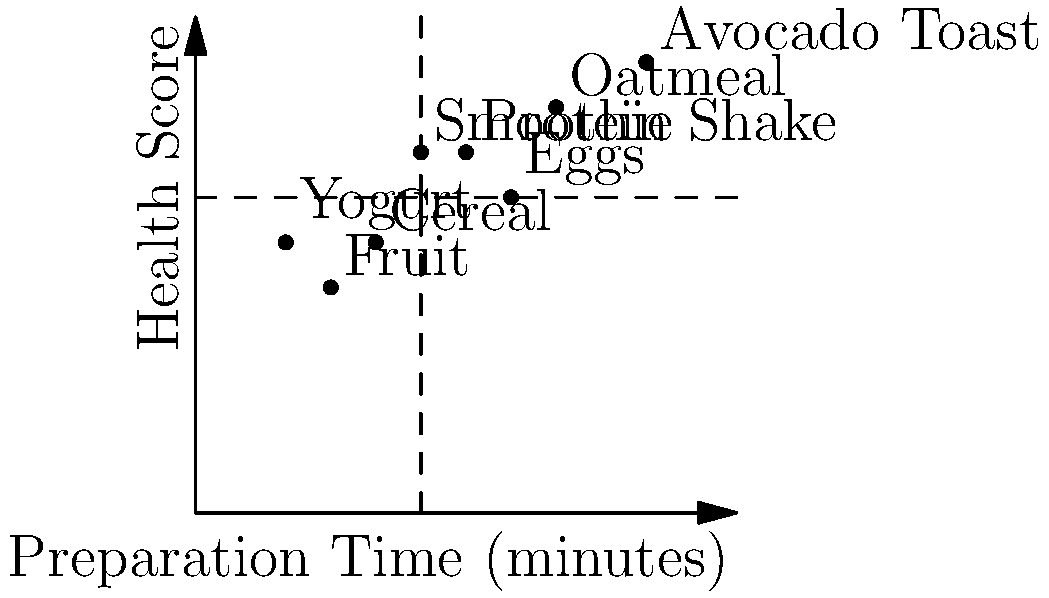Based on the scatter plot showing various breakfast options, their preparation times, and health scores, which options would be most suitable for a quick (under 5 minutes) and healthy (health score above 7) breakfast? To answer this question, we need to analyze the scatter plot and identify the breakfast options that meet both criteria:
1. Preparation time under 5 minutes
2. Health score above 7

Step 1: Identify the relevant quadrant
The ideal options will be located in the upper-left quadrant of the plot, defined by the intersection of the vertical line at x=5 (preparation time) and the horizontal line at y=7 (health score).

Step 2: Analyze each option
- Yogurt: Prep time ≈ 2 min, Health score ≈ 6 (Quick but not healthy enough)
- Smoothie: Prep time ≈ 5 min, Health score ≈ 8 (Borderline prep time, healthy)
- Oatmeal: Prep time ≈ 8 min, Health score ≈ 9 (Too long prep time)
- Fruit: Prep time ≈ 3 min, Health score ≈ 5 (Quick but not healthy enough)
- Avocado Toast: Prep time ≈ 10 min, Health score ≈ 10 (Too long prep time)
- Eggs: Prep time ≈ 7 min, Health score ≈ 7 (Too long prep time)
- Cereal: Prep time ≈ 4 min, Health score ≈ 6 (Quick but not healthy enough)
- Protein Shake: Prep time ≈ 6 min, Health score ≈ 8 (Too long prep time)

Step 3: Identify options meeting both criteria
The only option that falls in the desired quadrant (upper-left) is the Smoothie, with a preparation time of about 5 minutes and a health score of 8.

Step 4: Consider borderline options
While not strictly under 5 minutes, the Protein Shake is close (6 minutes) and has a high health score (8). It could be considered as an alternative if the preparation time can be slightly optimized.
Answer: Smoothie 